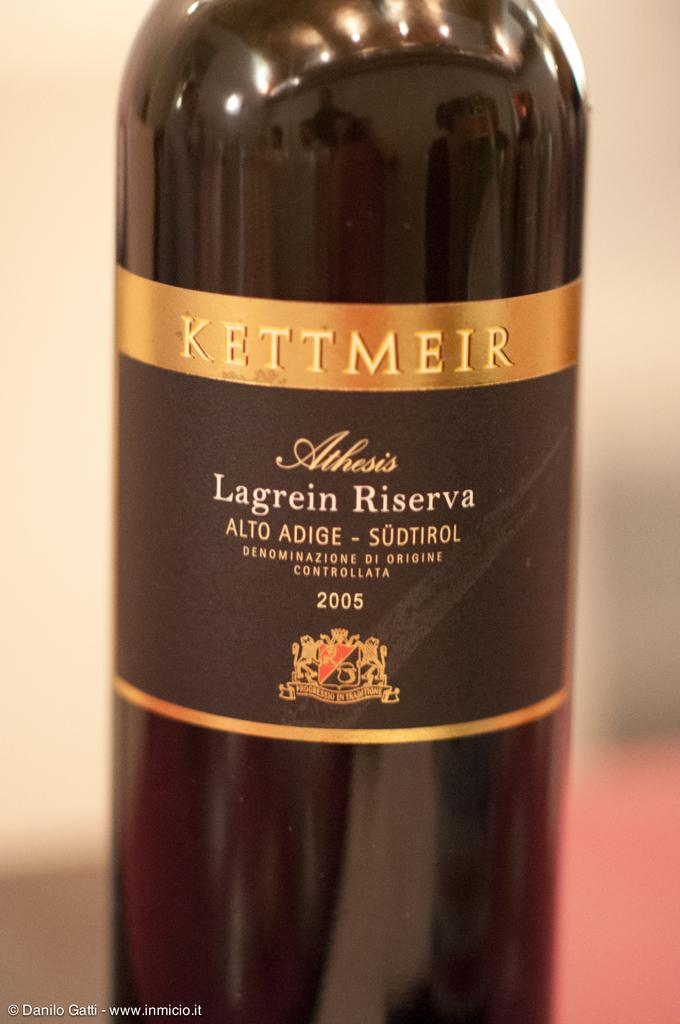<image>
Render a clear and concise summary of the photo. the word Lagrein that is on a bottle 